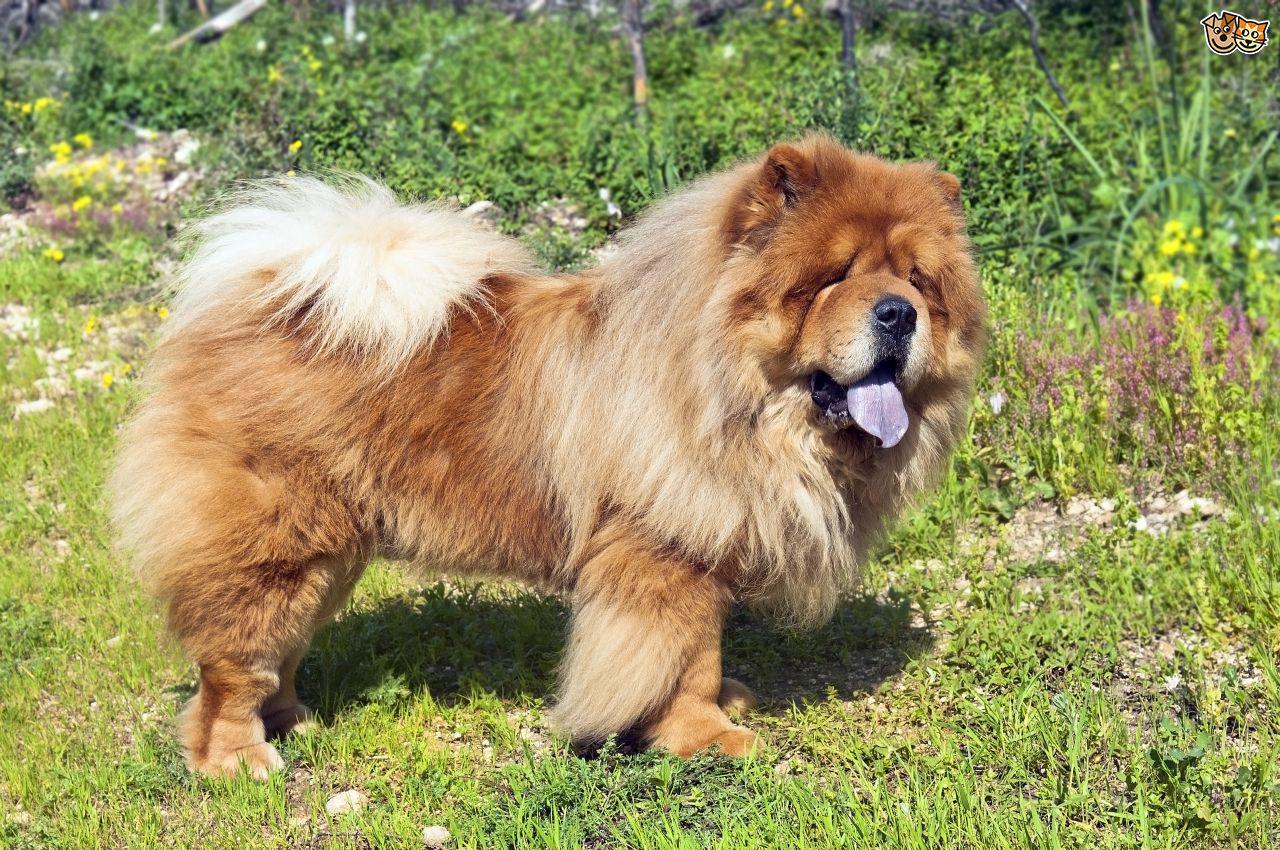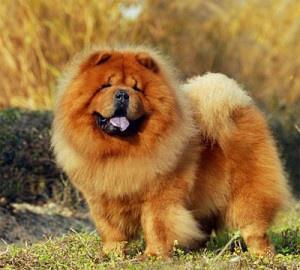The first image is the image on the left, the second image is the image on the right. Evaluate the accuracy of this statement regarding the images: "The right image includes an adult chow reclining on the grass facing rightward.". Is it true? Answer yes or no. No. 